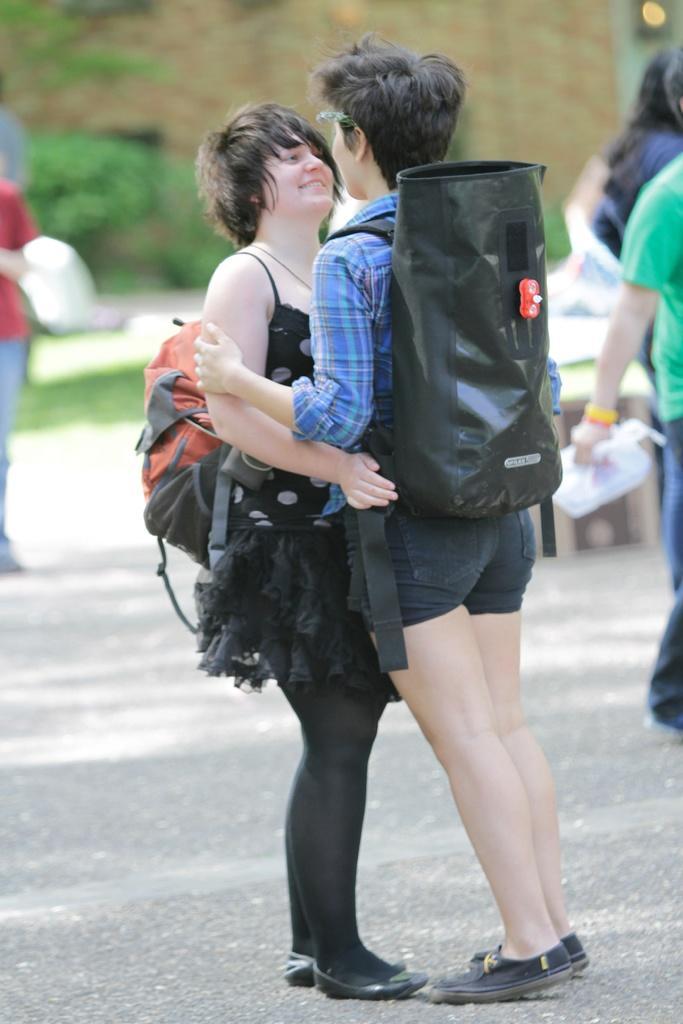Can you describe this image briefly? There are two persons standing and wearing a backpack in the middle of this image, and there are some other persons and trees in the background. 